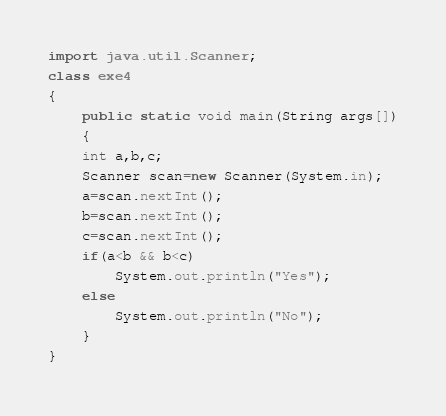Convert code to text. <code><loc_0><loc_0><loc_500><loc_500><_Java_>import java.util.Scanner;
class exe4
{
    public static void main(String args[])
    {
	int a,b,c;
	Scanner scan=new Scanner(System.in);
	a=scan.nextInt();
	b=scan.nextInt();
	c=scan.nextInt();
	if(a<b && b<c)
	    System.out.println("Yes");
	else
	    System.out.println("No");
    }
}</code> 